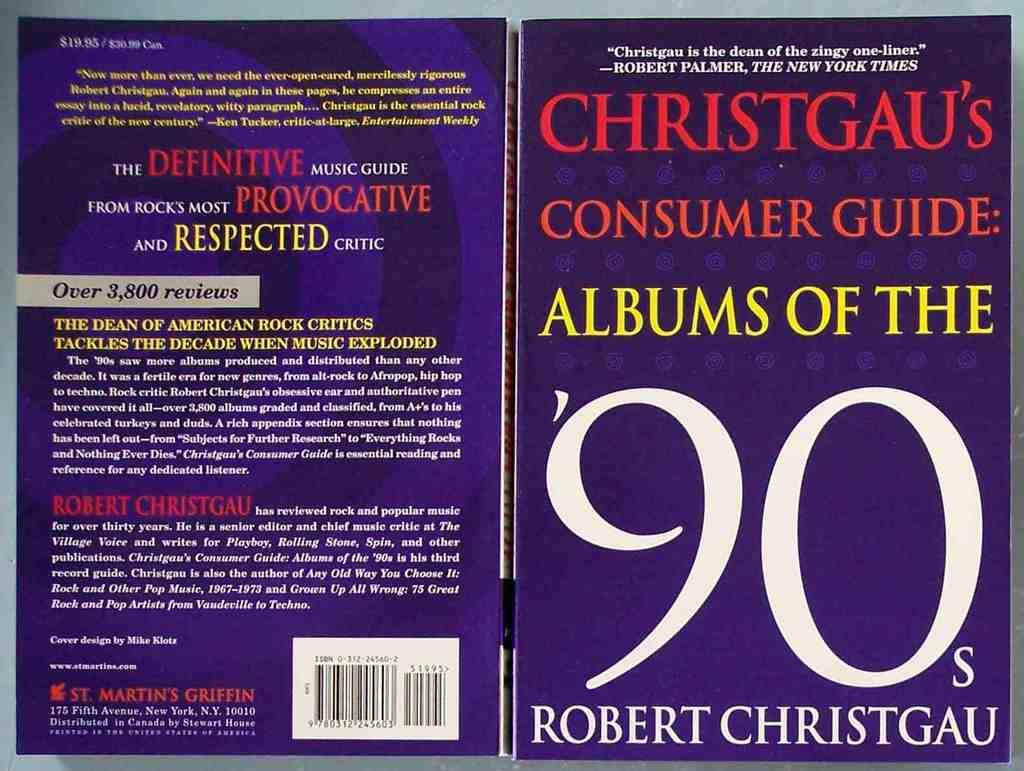<image>
Give a short and clear explanation of the subsequent image. purple book, christgau's consumer guide: albums of the '90s 